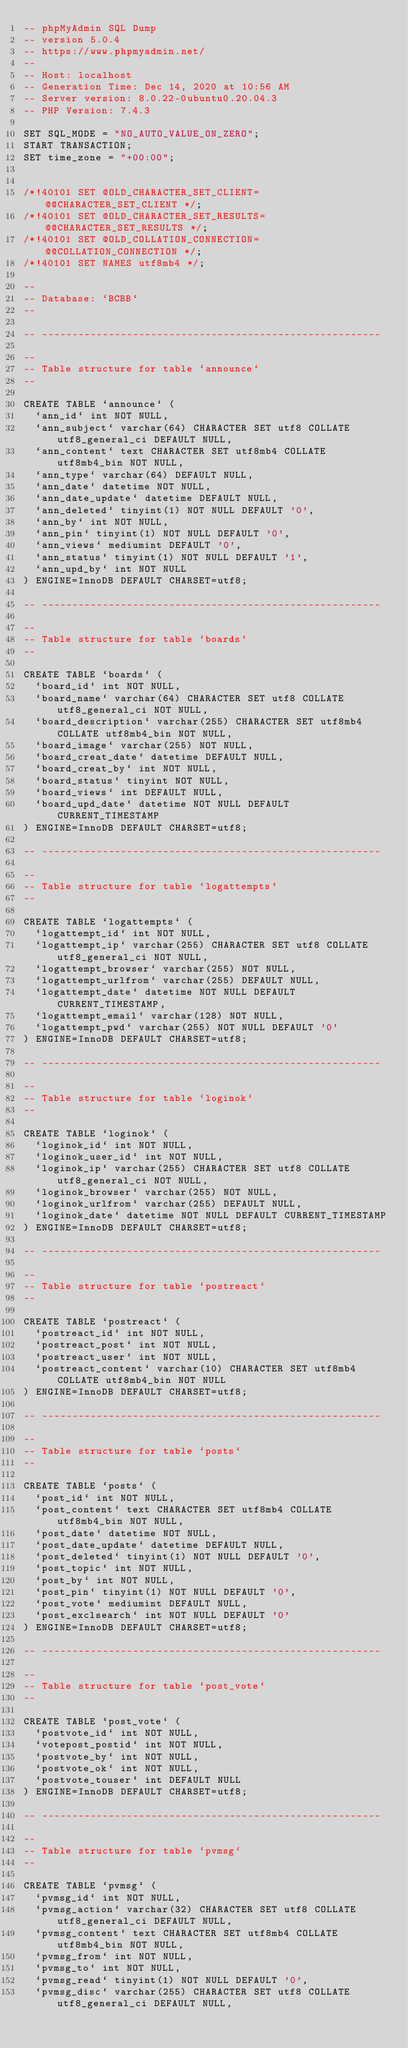Convert code to text. <code><loc_0><loc_0><loc_500><loc_500><_SQL_>-- phpMyAdmin SQL Dump
-- version 5.0.4
-- https://www.phpmyadmin.net/
--
-- Host: localhost
-- Generation Time: Dec 14, 2020 at 10:56 AM
-- Server version: 8.0.22-0ubuntu0.20.04.3
-- PHP Version: 7.4.3

SET SQL_MODE = "NO_AUTO_VALUE_ON_ZERO";
START TRANSACTION;
SET time_zone = "+00:00";


/*!40101 SET @OLD_CHARACTER_SET_CLIENT=@@CHARACTER_SET_CLIENT */;
/*!40101 SET @OLD_CHARACTER_SET_RESULTS=@@CHARACTER_SET_RESULTS */;
/*!40101 SET @OLD_COLLATION_CONNECTION=@@COLLATION_CONNECTION */;
/*!40101 SET NAMES utf8mb4 */;

--
-- Database: `BCBB`
--

-- --------------------------------------------------------

--
-- Table structure for table `announce`
--

CREATE TABLE `announce` (
  `ann_id` int NOT NULL,
  `ann_subject` varchar(64) CHARACTER SET utf8 COLLATE utf8_general_ci DEFAULT NULL,
  `ann_content` text CHARACTER SET utf8mb4 COLLATE utf8mb4_bin NOT NULL,
  `ann_type` varchar(64) DEFAULT NULL,
  `ann_date` datetime NOT NULL,
  `ann_date_update` datetime DEFAULT NULL,
  `ann_deleted` tinyint(1) NOT NULL DEFAULT '0',
  `ann_by` int NOT NULL,
  `ann_pin` tinyint(1) NOT NULL DEFAULT '0',
  `ann_views` mediumint DEFAULT '0',
  `ann_status` tinyint(1) NOT NULL DEFAULT '1',
  `ann_upd_by` int NOT NULL
) ENGINE=InnoDB DEFAULT CHARSET=utf8;

-- --------------------------------------------------------

--
-- Table structure for table `boards`
--

CREATE TABLE `boards` (
  `board_id` int NOT NULL,
  `board_name` varchar(64) CHARACTER SET utf8 COLLATE utf8_general_ci NOT NULL,
  `board_description` varchar(255) CHARACTER SET utf8mb4 COLLATE utf8mb4_bin NOT NULL,
  `board_image` varchar(255) NOT NULL,
  `board_creat_date` datetime DEFAULT NULL,
  `board_creat_by` int NOT NULL,
  `board_status` tinyint NOT NULL,
  `board_views` int DEFAULT NULL,
  `board_upd_date` datetime NOT NULL DEFAULT CURRENT_TIMESTAMP
) ENGINE=InnoDB DEFAULT CHARSET=utf8;

-- --------------------------------------------------------

--
-- Table structure for table `logattempts`
--

CREATE TABLE `logattempts` (
  `logattempt_id` int NOT NULL,
  `logattempt_ip` varchar(255) CHARACTER SET utf8 COLLATE utf8_general_ci NOT NULL,
  `logattempt_browser` varchar(255) NOT NULL,
  `logattempt_urlfrom` varchar(255) DEFAULT NULL,
  `logattempt_date` datetime NOT NULL DEFAULT CURRENT_TIMESTAMP,
  `logattempt_email` varchar(128) NOT NULL,
  `logattempt_pwd` varchar(255) NOT NULL DEFAULT '0'
) ENGINE=InnoDB DEFAULT CHARSET=utf8;

-- --------------------------------------------------------

--
-- Table structure for table `loginok`
--

CREATE TABLE `loginok` (
  `loginok_id` int NOT NULL,
  `loginok_user_id` int NOT NULL,
  `loginok_ip` varchar(255) CHARACTER SET utf8 COLLATE utf8_general_ci NOT NULL,
  `loginok_browser` varchar(255) NOT NULL,
  `loginok_urlfrom` varchar(255) DEFAULT NULL,
  `loginok_date` datetime NOT NULL DEFAULT CURRENT_TIMESTAMP
) ENGINE=InnoDB DEFAULT CHARSET=utf8;

-- --------------------------------------------------------

--
-- Table structure for table `postreact`
--

CREATE TABLE `postreact` (
  `postreact_id` int NOT NULL,
  `postreact_post` int NOT NULL,
  `postreact_user` int NOT NULL,
  `postreact_content` varchar(10) CHARACTER SET utf8mb4 COLLATE utf8mb4_bin NOT NULL
) ENGINE=InnoDB DEFAULT CHARSET=utf8;

-- --------------------------------------------------------

--
-- Table structure for table `posts`
--

CREATE TABLE `posts` (
  `post_id` int NOT NULL,
  `post_content` text CHARACTER SET utf8mb4 COLLATE utf8mb4_bin NOT NULL,
  `post_date` datetime NOT NULL,
  `post_date_update` datetime DEFAULT NULL,
  `post_deleted` tinyint(1) NOT NULL DEFAULT '0',
  `post_topic` int NOT NULL,
  `post_by` int NOT NULL,
  `post_pin` tinyint(1) NOT NULL DEFAULT '0',
  `post_vote` mediumint DEFAULT NULL,
  `post_exclsearch` int NOT NULL DEFAULT '0'
) ENGINE=InnoDB DEFAULT CHARSET=utf8;

-- --------------------------------------------------------

--
-- Table structure for table `post_vote`
--

CREATE TABLE `post_vote` (
  `postvote_id` int NOT NULL,
  `votepost_postid` int NOT NULL,
  `postvote_by` int NOT NULL,
  `postvote_ok` int NOT NULL,
  `postvote_touser` int DEFAULT NULL
) ENGINE=InnoDB DEFAULT CHARSET=utf8;

-- --------------------------------------------------------

--
-- Table structure for table `pvmsg`
--

CREATE TABLE `pvmsg` (
  `pvmsg_id` int NOT NULL,
  `pvmsg_action` varchar(32) CHARACTER SET utf8 COLLATE utf8_general_ci DEFAULT NULL,
  `pvmsg_content` text CHARACTER SET utf8mb4 COLLATE utf8mb4_bin NOT NULL,
  `pvmsg_from` int NOT NULL,
  `pvmsg_to` int NOT NULL,
  `pvmsg_read` tinyint(1) NOT NULL DEFAULT '0',
  `pvmsg_disc` varchar(255) CHARACTER SET utf8 COLLATE utf8_general_ci DEFAULT NULL,</code> 